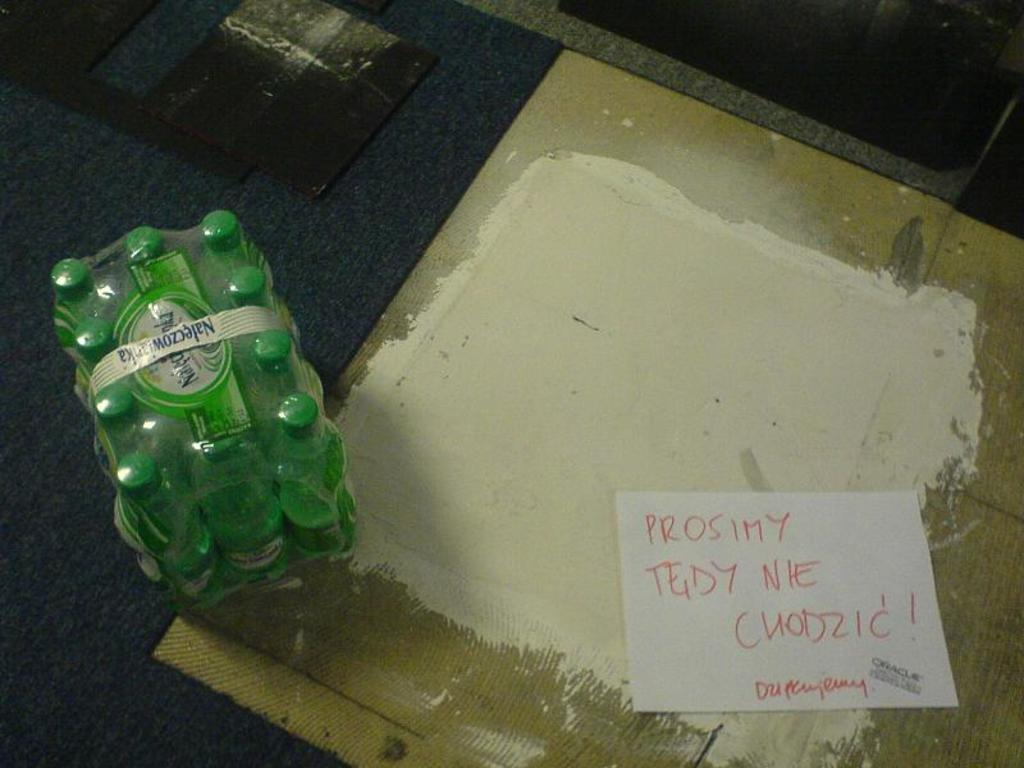What is covering the floor in the image? A carpet is placed on the floor in the image. What else can be seen on the floor besides the carpet? There are sealed bottles on the floor. Is there any written information present in the image? Yes, there is a note in the image. What type of celery is being used to decorate the carpet in the image? There is no celery present in the image; it features a carpet, sealed bottles, and a note. How many pies are visible on the floor in the image? There are no pies visible in the image; it features a carpet, sealed bottles, and a note. 